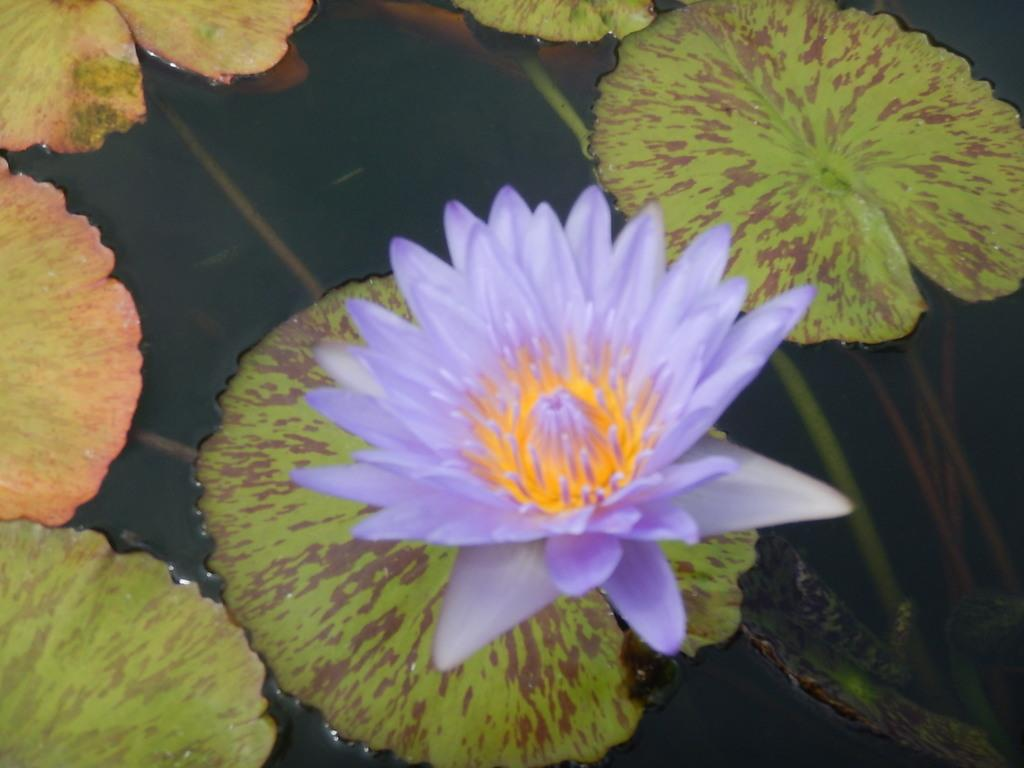What is the main subject of the image? There is a flower in the center of the image. What can be seen in the background of the image? There are leaves in the background of the image. What else is visible in the image besides the flower and leaves? There is water visible in the image. What type of eggnog can be seen in the image? There is no eggnog present in the image. What kind of musical instruments are being played by the band in the image? There is no band present in the image. 